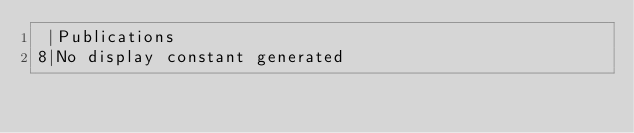Convert code to text. <code><loc_0><loc_0><loc_500><loc_500><_SQL_> |Publications 
8|No display constant generated </code> 